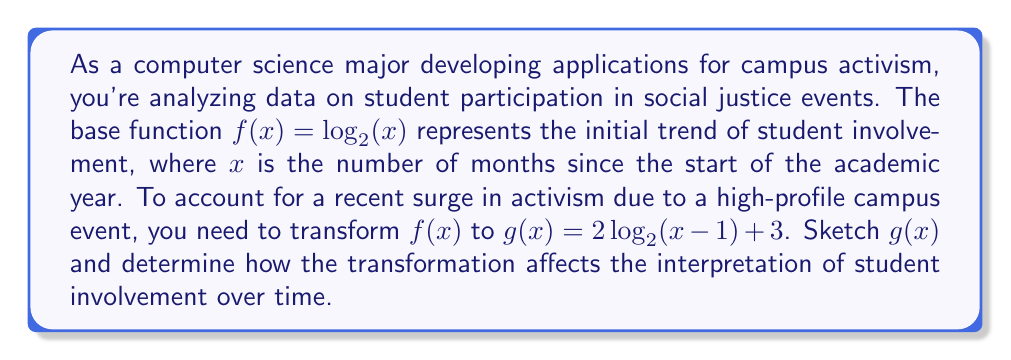Solve this math problem. To understand how $g(x) = 2\log_2(x-1) + 3$ transforms $f(x) = \log_2(x)$, let's break down the steps:

1. Inside the function: $(x-1)$
   This shifts the function 1 unit to the right. The domain becomes $x > 1$.

2. Outside the function: $2\log_2(x-1)$
   This vertically stretches the function by a factor of 2.

3. Vertical shift: $+3$
   This moves the entire function up by 3 units.

To sketch $g(x)$:
- The y-intercept doesn't exist as $x$ must be greater than 1.
- The vertical asymptote is at $x = 1$.
- As $x$ increases, $g(x)$ grows more slowly than $f(x)$ but reaches higher values.

Interpretation:
- The shift right $(x-1)$ indicates a delay in student involvement, possibly due to initial unawareness of the event.
- The vertical stretch (multiplying by 2) shows a more rapid increase in participation once students engage.
- The upward shift (+3) represents a higher baseline of involvement, likely due to increased awareness from the high-profile event.

Overall, $g(x)$ suggests that while student involvement may have a delayed start, it then grows more quickly and maintains a higher level compared to the original trend.

[asy]
import graph;
size(200,200);
real f(real x) {return log(x)/log(2);}
real g(real x) {return 2*log(x-1)/log(2)+3;}
draw(graph(f,0.1,10),blue);
draw(graph(g,1.1,10),red);
xaxis("x",arrow=Arrow);
yaxis("y",arrow=Arrow);
label("f(x)",(-0.5,f(8)),blue);
label("g(x)",(8,g(8)),red);
[/asy]
Answer: $g(x)$ shows delayed but accelerated and sustained higher student involvement. 